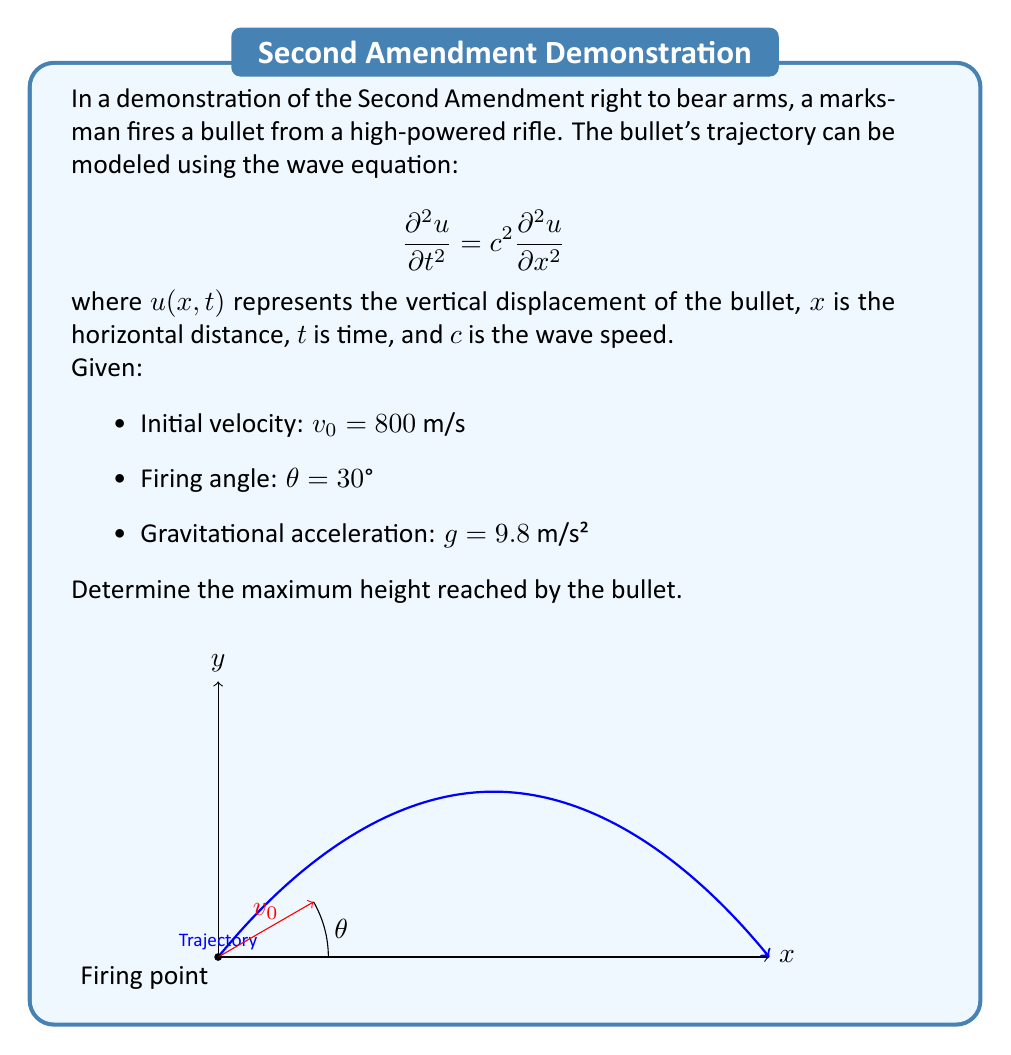Solve this math problem. To solve this problem, we'll use the equations of motion for projectile motion, which are derived from the wave equation under gravitational influence:

1) Vertical displacement equation:
   $$y(t) = v_0 \sin(\theta) t - \frac{1}{2}gt^2$$

2) To find the maximum height, we need to find the time when the vertical velocity is zero:
   $$\frac{dy}{dt} = v_0 \sin(\theta) - gt = 0$$

3) Solve for t:
   $$t_{max} = \frac{v_0 \sin(\theta)}{g}$$

4) Substitute the given values:
   $$t_{max} = \frac{800 \sin(30°)}{9.8} = \frac{800 \cdot 0.5}{9.8} \approx 40.82 \text{ seconds}$$

5) Now, substitute this time back into the vertical displacement equation:
   $$y_{max} = v_0 \sin(\theta) \cdot t_{max} - \frac{1}{2}g \cdot t_{max}^2$$
   $$y_{max} = 800 \cdot 0.5 \cdot 40.82 - \frac{1}{2} \cdot 9.8 \cdot 40.82^2$$

6) Calculate:
   $$y_{max} = 16,328 - 8,164 = 8,164 \text{ meters}$$

Therefore, the maximum height reached by the bullet is approximately 8,164 meters.
Answer: 8,164 meters 